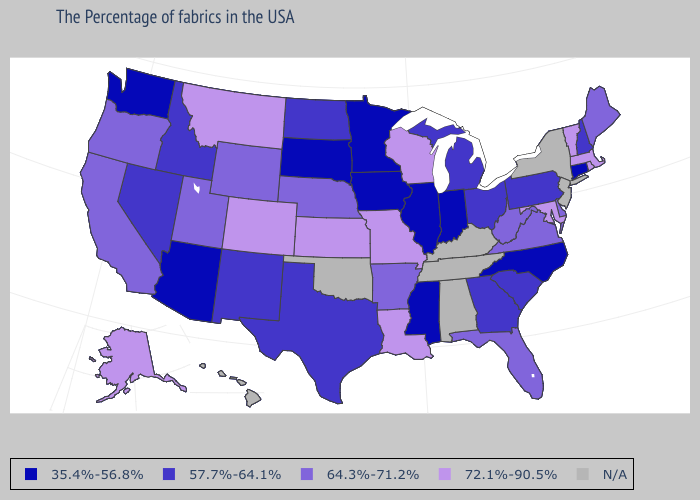Among the states that border Alabama , which have the highest value?
Short answer required. Florida. Does the map have missing data?
Be succinct. Yes. Among the states that border Alabama , does Florida have the highest value?
Answer briefly. Yes. Name the states that have a value in the range 72.1%-90.5%?
Answer briefly. Massachusetts, Rhode Island, Vermont, Maryland, Wisconsin, Louisiana, Missouri, Kansas, Colorado, Montana, Alaska. Name the states that have a value in the range 35.4%-56.8%?
Short answer required. Connecticut, North Carolina, Indiana, Illinois, Mississippi, Minnesota, Iowa, South Dakota, Arizona, Washington. Does New Mexico have the lowest value in the USA?
Give a very brief answer. No. Does the first symbol in the legend represent the smallest category?
Answer briefly. Yes. What is the value of Montana?
Answer briefly. 72.1%-90.5%. What is the lowest value in the USA?
Quick response, please. 35.4%-56.8%. Which states have the lowest value in the Northeast?
Write a very short answer. Connecticut. Name the states that have a value in the range 57.7%-64.1%?
Quick response, please. New Hampshire, Pennsylvania, South Carolina, Ohio, Georgia, Michigan, Texas, North Dakota, New Mexico, Idaho, Nevada. Among the states that border Alabama , which have the highest value?
Quick response, please. Florida. Which states have the lowest value in the West?
Give a very brief answer. Arizona, Washington. 